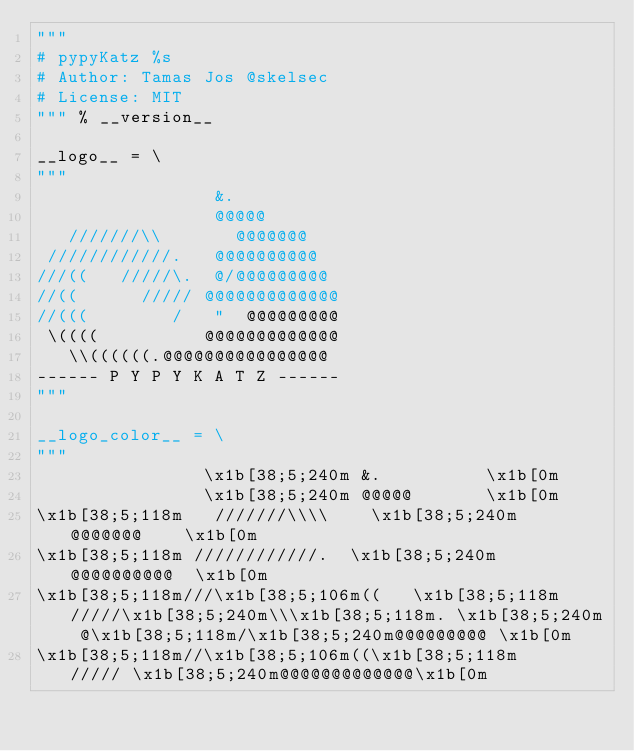<code> <loc_0><loc_0><loc_500><loc_500><_Python_>"""
# pypyKatz %s 
# Author: Tamas Jos @skelsec
# License: MIT
""" % __version__

__logo__ = \
"""
                 &.          
                 @@@@@       
   ///////\\       @@@@@@@    
 ////////////.   @@@@@@@@@@  
///((   /////\.  @/@@@@@@@@@ 
//((      ///// @@@@@@@@@@@@@
//(((        /   "  @@@@@@@@@
 \((((          @@@@@@@@@@@@@
   \\((((((.@@@@@@@@@@@@@@@@ 
------ P Y P Y K A T Z ------
"""

__logo_color__ = \
"""
                \x1b[38;5;240m &.          \x1b[0m
                \x1b[38;5;240m @@@@@       \x1b[0m
\x1b[38;5;118m   ///////\\\\    \x1b[38;5;240m  @@@@@@@    \x1b[0m
\x1b[38;5;118m ////////////.  \x1b[38;5;240m @@@@@@@@@@  \x1b[0m
\x1b[38;5;118m///\x1b[38;5;106m((   \x1b[38;5;118m/////\x1b[38;5;240m\\\x1b[38;5;118m. \x1b[38;5;240m @\x1b[38;5;118m/\x1b[38;5;240m@@@@@@@@@ \x1b[0m
\x1b[38;5;118m//\x1b[38;5;106m((\x1b[38;5;118m      ///// \x1b[38;5;240m@@@@@@@@@@@@@\x1b[0m</code> 